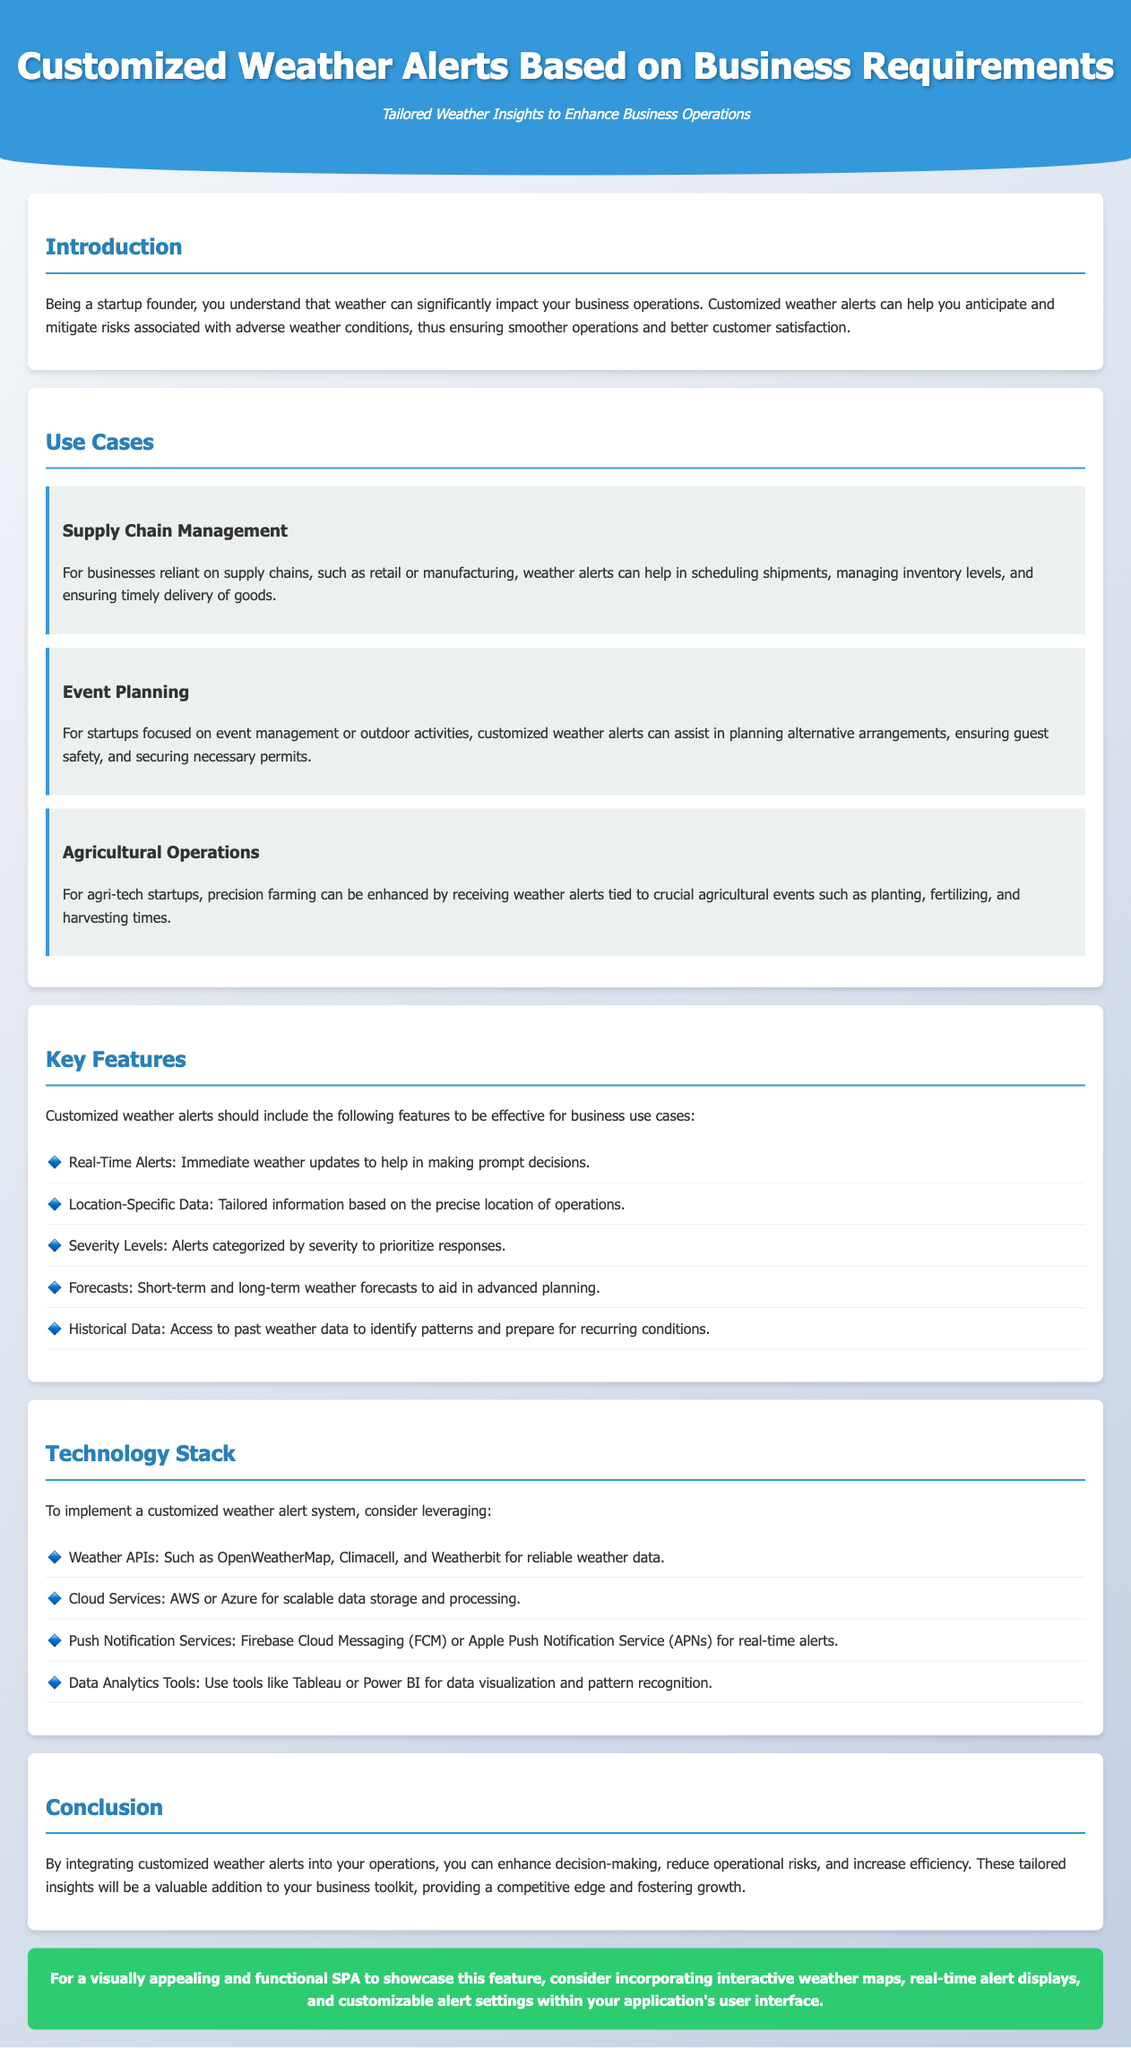What are customized weather alerts designed to enhance? Customized weather alerts are designed to enhance business operations by helping to anticipate and mitigate risks associated with adverse weather conditions.
Answer: Business operations Which use case is related to outdoor activities? The use case related to outdoor activities is concerned with event management, where customized weather alerts assist in planning alternative arrangements.
Answer: Event Planning What feature ensures immediate decision-making? The feature that ensures immediate decision-making is real-time alerts, providing immediate weather updates.
Answer: Real-Time Alerts Name one technology used for reliable weather data. One technology used for reliable weather data is Weather APIs.
Answer: Weather APIs How many key features of customized weather alerts are listed? The document lists five key features of customized weather alerts intended for business use cases.
Answer: Five What is the recommended cloud service provider mentioned? The recommended cloud service providers mentioned include AWS or Azure for scalable data storage and processing.
Answer: AWS or Azure In which section is the introduction found? The introduction is found in the Introduction section of the document.
Answer: Introduction What is the color of the recommendation section? The recommendation section has a background color of green, specifically #2ecc71.
Answer: Green 